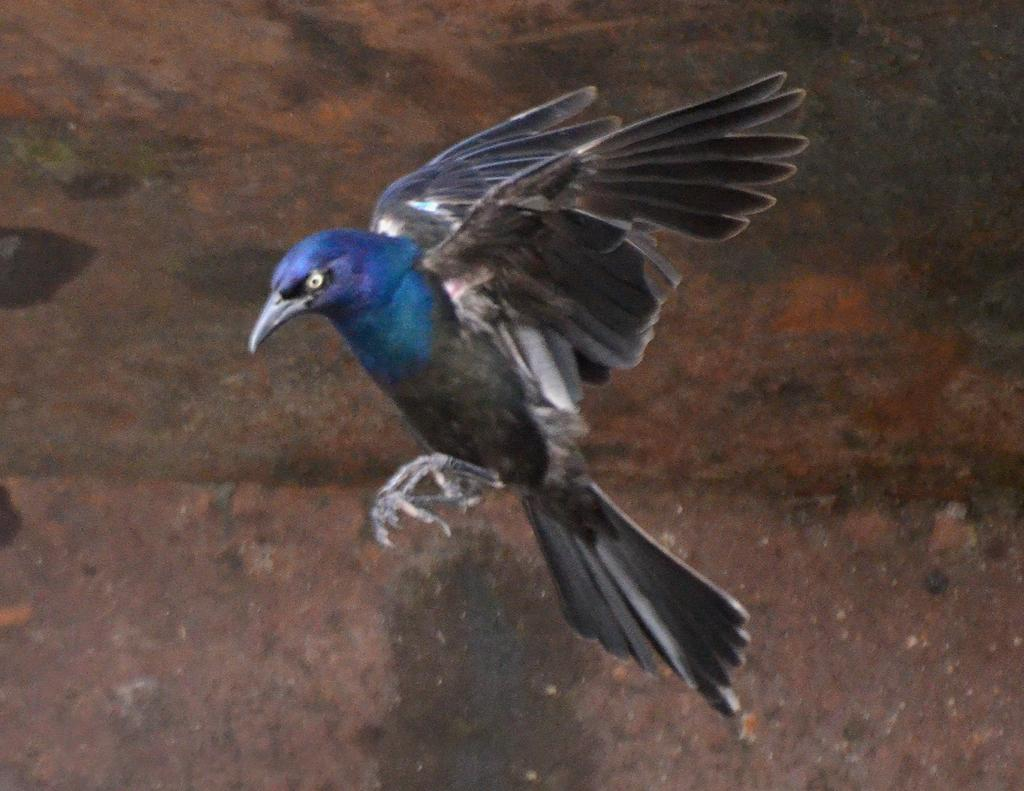What type of animal can be seen in the image? There is a bird in the image. What is the bird doing in the image? The bird is flying towards the left side. What color is the background of the image? The background color is brown. What type of skirt is the bird wearing in the image? Birds do not wear skirts, so this question cannot be answered. 